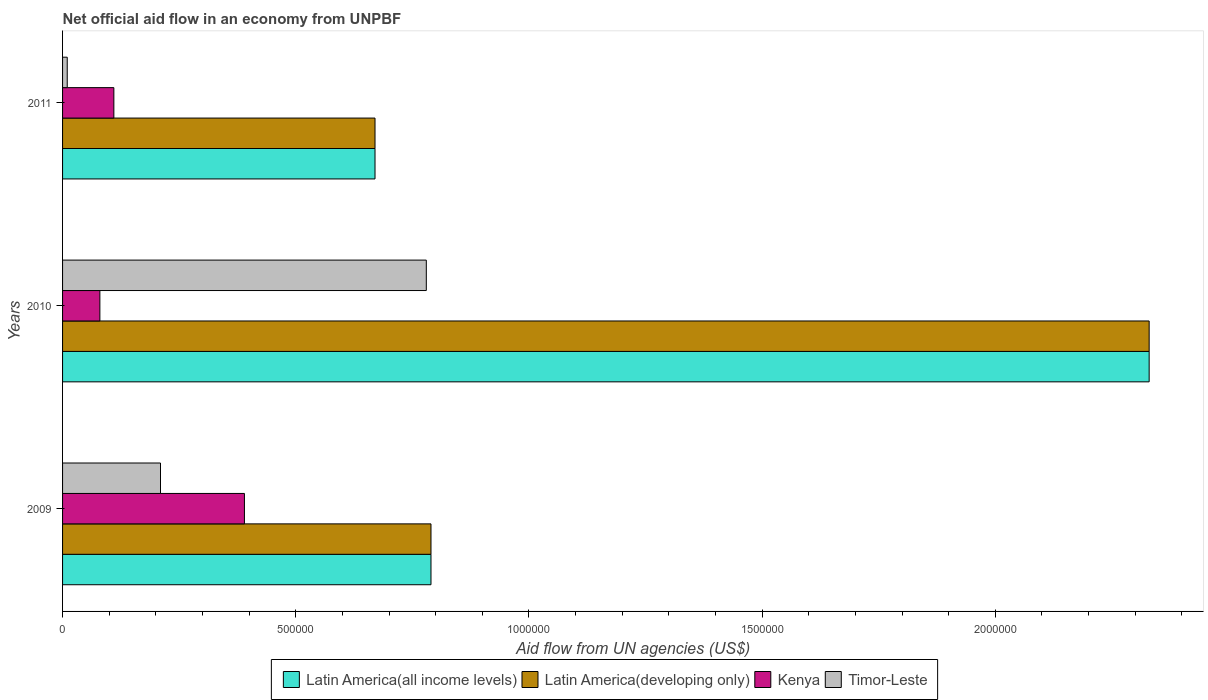How many different coloured bars are there?
Ensure brevity in your answer.  4. In how many cases, is the number of bars for a given year not equal to the number of legend labels?
Your answer should be compact. 0. Across all years, what is the maximum net official aid flow in Latin America(developing only)?
Offer a terse response. 2.33e+06. Across all years, what is the minimum net official aid flow in Timor-Leste?
Make the answer very short. 10000. In which year was the net official aid flow in Timor-Leste maximum?
Offer a terse response. 2010. In which year was the net official aid flow in Latin America(developing only) minimum?
Provide a short and direct response. 2011. What is the total net official aid flow in Latin America(all income levels) in the graph?
Your answer should be very brief. 3.79e+06. What is the difference between the net official aid flow in Latin America(developing only) in 2009 and that in 2010?
Your answer should be compact. -1.54e+06. What is the difference between the net official aid flow in Latin America(developing only) in 2010 and the net official aid flow in Latin America(all income levels) in 2011?
Offer a very short reply. 1.66e+06. What is the average net official aid flow in Timor-Leste per year?
Your response must be concise. 3.33e+05. In the year 2011, what is the difference between the net official aid flow in Latin America(all income levels) and net official aid flow in Kenya?
Offer a terse response. 5.60e+05. What is the ratio of the net official aid flow in Timor-Leste in 2009 to that in 2011?
Provide a short and direct response. 21. Is the difference between the net official aid flow in Latin America(all income levels) in 2009 and 2011 greater than the difference between the net official aid flow in Kenya in 2009 and 2011?
Make the answer very short. No. What is the difference between the highest and the second highest net official aid flow in Timor-Leste?
Give a very brief answer. 5.70e+05. What is the difference between the highest and the lowest net official aid flow in Latin America(developing only)?
Give a very brief answer. 1.66e+06. In how many years, is the net official aid flow in Timor-Leste greater than the average net official aid flow in Timor-Leste taken over all years?
Offer a terse response. 1. What does the 1st bar from the top in 2010 represents?
Give a very brief answer. Timor-Leste. What does the 1st bar from the bottom in 2009 represents?
Offer a terse response. Latin America(all income levels). Is it the case that in every year, the sum of the net official aid flow in Kenya and net official aid flow in Latin America(all income levels) is greater than the net official aid flow in Timor-Leste?
Your response must be concise. Yes. How many bars are there?
Your answer should be very brief. 12. How many years are there in the graph?
Make the answer very short. 3. Does the graph contain any zero values?
Provide a succinct answer. No. How many legend labels are there?
Your answer should be compact. 4. What is the title of the graph?
Your response must be concise. Net official aid flow in an economy from UNPBF. Does "United Kingdom" appear as one of the legend labels in the graph?
Your response must be concise. No. What is the label or title of the X-axis?
Offer a very short reply. Aid flow from UN agencies (US$). What is the Aid flow from UN agencies (US$) in Latin America(all income levels) in 2009?
Make the answer very short. 7.90e+05. What is the Aid flow from UN agencies (US$) in Latin America(developing only) in 2009?
Offer a very short reply. 7.90e+05. What is the Aid flow from UN agencies (US$) of Latin America(all income levels) in 2010?
Keep it short and to the point. 2.33e+06. What is the Aid flow from UN agencies (US$) in Latin America(developing only) in 2010?
Provide a short and direct response. 2.33e+06. What is the Aid flow from UN agencies (US$) in Timor-Leste in 2010?
Provide a succinct answer. 7.80e+05. What is the Aid flow from UN agencies (US$) in Latin America(all income levels) in 2011?
Your response must be concise. 6.70e+05. What is the Aid flow from UN agencies (US$) of Latin America(developing only) in 2011?
Ensure brevity in your answer.  6.70e+05. What is the Aid flow from UN agencies (US$) of Kenya in 2011?
Your answer should be very brief. 1.10e+05. Across all years, what is the maximum Aid flow from UN agencies (US$) in Latin America(all income levels)?
Make the answer very short. 2.33e+06. Across all years, what is the maximum Aid flow from UN agencies (US$) in Latin America(developing only)?
Your answer should be compact. 2.33e+06. Across all years, what is the maximum Aid flow from UN agencies (US$) in Timor-Leste?
Your answer should be compact. 7.80e+05. Across all years, what is the minimum Aid flow from UN agencies (US$) of Latin America(all income levels)?
Offer a terse response. 6.70e+05. Across all years, what is the minimum Aid flow from UN agencies (US$) in Latin America(developing only)?
Your response must be concise. 6.70e+05. Across all years, what is the minimum Aid flow from UN agencies (US$) of Kenya?
Ensure brevity in your answer.  8.00e+04. What is the total Aid flow from UN agencies (US$) in Latin America(all income levels) in the graph?
Offer a very short reply. 3.79e+06. What is the total Aid flow from UN agencies (US$) of Latin America(developing only) in the graph?
Offer a terse response. 3.79e+06. What is the total Aid flow from UN agencies (US$) in Kenya in the graph?
Provide a short and direct response. 5.80e+05. What is the difference between the Aid flow from UN agencies (US$) in Latin America(all income levels) in 2009 and that in 2010?
Give a very brief answer. -1.54e+06. What is the difference between the Aid flow from UN agencies (US$) of Latin America(developing only) in 2009 and that in 2010?
Keep it short and to the point. -1.54e+06. What is the difference between the Aid flow from UN agencies (US$) of Kenya in 2009 and that in 2010?
Your answer should be compact. 3.10e+05. What is the difference between the Aid flow from UN agencies (US$) in Timor-Leste in 2009 and that in 2010?
Offer a very short reply. -5.70e+05. What is the difference between the Aid flow from UN agencies (US$) in Latin America(developing only) in 2009 and that in 2011?
Your answer should be compact. 1.20e+05. What is the difference between the Aid flow from UN agencies (US$) of Kenya in 2009 and that in 2011?
Ensure brevity in your answer.  2.80e+05. What is the difference between the Aid flow from UN agencies (US$) in Timor-Leste in 2009 and that in 2011?
Ensure brevity in your answer.  2.00e+05. What is the difference between the Aid flow from UN agencies (US$) of Latin America(all income levels) in 2010 and that in 2011?
Provide a succinct answer. 1.66e+06. What is the difference between the Aid flow from UN agencies (US$) in Latin America(developing only) in 2010 and that in 2011?
Make the answer very short. 1.66e+06. What is the difference between the Aid flow from UN agencies (US$) in Timor-Leste in 2010 and that in 2011?
Give a very brief answer. 7.70e+05. What is the difference between the Aid flow from UN agencies (US$) of Latin America(all income levels) in 2009 and the Aid flow from UN agencies (US$) of Latin America(developing only) in 2010?
Keep it short and to the point. -1.54e+06. What is the difference between the Aid flow from UN agencies (US$) in Latin America(all income levels) in 2009 and the Aid flow from UN agencies (US$) in Kenya in 2010?
Provide a succinct answer. 7.10e+05. What is the difference between the Aid flow from UN agencies (US$) in Latin America(developing only) in 2009 and the Aid flow from UN agencies (US$) in Kenya in 2010?
Your response must be concise. 7.10e+05. What is the difference between the Aid flow from UN agencies (US$) of Kenya in 2009 and the Aid flow from UN agencies (US$) of Timor-Leste in 2010?
Make the answer very short. -3.90e+05. What is the difference between the Aid flow from UN agencies (US$) in Latin America(all income levels) in 2009 and the Aid flow from UN agencies (US$) in Latin America(developing only) in 2011?
Offer a terse response. 1.20e+05. What is the difference between the Aid flow from UN agencies (US$) of Latin America(all income levels) in 2009 and the Aid flow from UN agencies (US$) of Kenya in 2011?
Your response must be concise. 6.80e+05. What is the difference between the Aid flow from UN agencies (US$) in Latin America(all income levels) in 2009 and the Aid flow from UN agencies (US$) in Timor-Leste in 2011?
Your answer should be very brief. 7.80e+05. What is the difference between the Aid flow from UN agencies (US$) of Latin America(developing only) in 2009 and the Aid flow from UN agencies (US$) of Kenya in 2011?
Give a very brief answer. 6.80e+05. What is the difference between the Aid flow from UN agencies (US$) of Latin America(developing only) in 2009 and the Aid flow from UN agencies (US$) of Timor-Leste in 2011?
Your answer should be very brief. 7.80e+05. What is the difference between the Aid flow from UN agencies (US$) of Latin America(all income levels) in 2010 and the Aid flow from UN agencies (US$) of Latin America(developing only) in 2011?
Offer a very short reply. 1.66e+06. What is the difference between the Aid flow from UN agencies (US$) of Latin America(all income levels) in 2010 and the Aid flow from UN agencies (US$) of Kenya in 2011?
Provide a succinct answer. 2.22e+06. What is the difference between the Aid flow from UN agencies (US$) in Latin America(all income levels) in 2010 and the Aid flow from UN agencies (US$) in Timor-Leste in 2011?
Give a very brief answer. 2.32e+06. What is the difference between the Aid flow from UN agencies (US$) in Latin America(developing only) in 2010 and the Aid flow from UN agencies (US$) in Kenya in 2011?
Your answer should be compact. 2.22e+06. What is the difference between the Aid flow from UN agencies (US$) in Latin America(developing only) in 2010 and the Aid flow from UN agencies (US$) in Timor-Leste in 2011?
Provide a short and direct response. 2.32e+06. What is the average Aid flow from UN agencies (US$) in Latin America(all income levels) per year?
Offer a very short reply. 1.26e+06. What is the average Aid flow from UN agencies (US$) in Latin America(developing only) per year?
Give a very brief answer. 1.26e+06. What is the average Aid flow from UN agencies (US$) in Kenya per year?
Provide a short and direct response. 1.93e+05. What is the average Aid flow from UN agencies (US$) in Timor-Leste per year?
Keep it short and to the point. 3.33e+05. In the year 2009, what is the difference between the Aid flow from UN agencies (US$) in Latin America(all income levels) and Aid flow from UN agencies (US$) in Timor-Leste?
Provide a succinct answer. 5.80e+05. In the year 2009, what is the difference between the Aid flow from UN agencies (US$) in Latin America(developing only) and Aid flow from UN agencies (US$) in Timor-Leste?
Keep it short and to the point. 5.80e+05. In the year 2009, what is the difference between the Aid flow from UN agencies (US$) of Kenya and Aid flow from UN agencies (US$) of Timor-Leste?
Give a very brief answer. 1.80e+05. In the year 2010, what is the difference between the Aid flow from UN agencies (US$) in Latin America(all income levels) and Aid flow from UN agencies (US$) in Kenya?
Your answer should be compact. 2.25e+06. In the year 2010, what is the difference between the Aid flow from UN agencies (US$) of Latin America(all income levels) and Aid flow from UN agencies (US$) of Timor-Leste?
Offer a terse response. 1.55e+06. In the year 2010, what is the difference between the Aid flow from UN agencies (US$) of Latin America(developing only) and Aid flow from UN agencies (US$) of Kenya?
Keep it short and to the point. 2.25e+06. In the year 2010, what is the difference between the Aid flow from UN agencies (US$) of Latin America(developing only) and Aid flow from UN agencies (US$) of Timor-Leste?
Provide a succinct answer. 1.55e+06. In the year 2010, what is the difference between the Aid flow from UN agencies (US$) in Kenya and Aid flow from UN agencies (US$) in Timor-Leste?
Your answer should be compact. -7.00e+05. In the year 2011, what is the difference between the Aid flow from UN agencies (US$) of Latin America(all income levels) and Aid flow from UN agencies (US$) of Kenya?
Ensure brevity in your answer.  5.60e+05. In the year 2011, what is the difference between the Aid flow from UN agencies (US$) of Latin America(developing only) and Aid flow from UN agencies (US$) of Kenya?
Offer a very short reply. 5.60e+05. In the year 2011, what is the difference between the Aid flow from UN agencies (US$) in Latin America(developing only) and Aid flow from UN agencies (US$) in Timor-Leste?
Offer a very short reply. 6.60e+05. In the year 2011, what is the difference between the Aid flow from UN agencies (US$) in Kenya and Aid flow from UN agencies (US$) in Timor-Leste?
Provide a succinct answer. 1.00e+05. What is the ratio of the Aid flow from UN agencies (US$) of Latin America(all income levels) in 2009 to that in 2010?
Your answer should be compact. 0.34. What is the ratio of the Aid flow from UN agencies (US$) in Latin America(developing only) in 2009 to that in 2010?
Offer a terse response. 0.34. What is the ratio of the Aid flow from UN agencies (US$) in Kenya in 2009 to that in 2010?
Keep it short and to the point. 4.88. What is the ratio of the Aid flow from UN agencies (US$) of Timor-Leste in 2009 to that in 2010?
Make the answer very short. 0.27. What is the ratio of the Aid flow from UN agencies (US$) of Latin America(all income levels) in 2009 to that in 2011?
Offer a very short reply. 1.18. What is the ratio of the Aid flow from UN agencies (US$) in Latin America(developing only) in 2009 to that in 2011?
Your response must be concise. 1.18. What is the ratio of the Aid flow from UN agencies (US$) in Kenya in 2009 to that in 2011?
Your response must be concise. 3.55. What is the ratio of the Aid flow from UN agencies (US$) in Latin America(all income levels) in 2010 to that in 2011?
Your answer should be very brief. 3.48. What is the ratio of the Aid flow from UN agencies (US$) in Latin America(developing only) in 2010 to that in 2011?
Provide a short and direct response. 3.48. What is the ratio of the Aid flow from UN agencies (US$) of Kenya in 2010 to that in 2011?
Keep it short and to the point. 0.73. What is the difference between the highest and the second highest Aid flow from UN agencies (US$) in Latin America(all income levels)?
Your response must be concise. 1.54e+06. What is the difference between the highest and the second highest Aid flow from UN agencies (US$) in Latin America(developing only)?
Make the answer very short. 1.54e+06. What is the difference between the highest and the second highest Aid flow from UN agencies (US$) in Kenya?
Offer a terse response. 2.80e+05. What is the difference between the highest and the second highest Aid flow from UN agencies (US$) in Timor-Leste?
Offer a very short reply. 5.70e+05. What is the difference between the highest and the lowest Aid flow from UN agencies (US$) in Latin America(all income levels)?
Your answer should be very brief. 1.66e+06. What is the difference between the highest and the lowest Aid flow from UN agencies (US$) of Latin America(developing only)?
Give a very brief answer. 1.66e+06. What is the difference between the highest and the lowest Aid flow from UN agencies (US$) of Timor-Leste?
Give a very brief answer. 7.70e+05. 